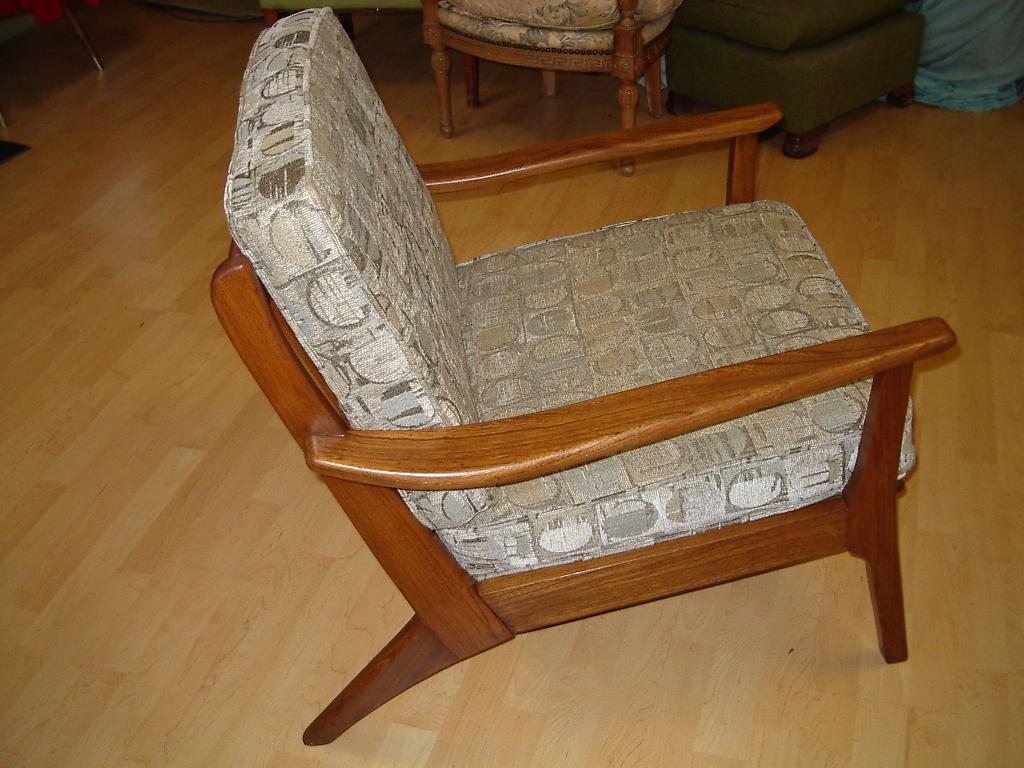What type of furniture is visible in the image? There are chairs and a table in the image. Where are the chairs and table located? The chairs and table are on the floor. Can you describe the object in the right top part of the image? Unfortunately, the provided facts do not give any information about the object in the right top part of the image. What type of bear can be seen causing destruction in the image? There is no bear or destruction present in the image. Can you tell me how the stranger interacts with the chairs and table in the image? There is no stranger present in the image, so it is not possible to describe any interactions with the chairs and table. 